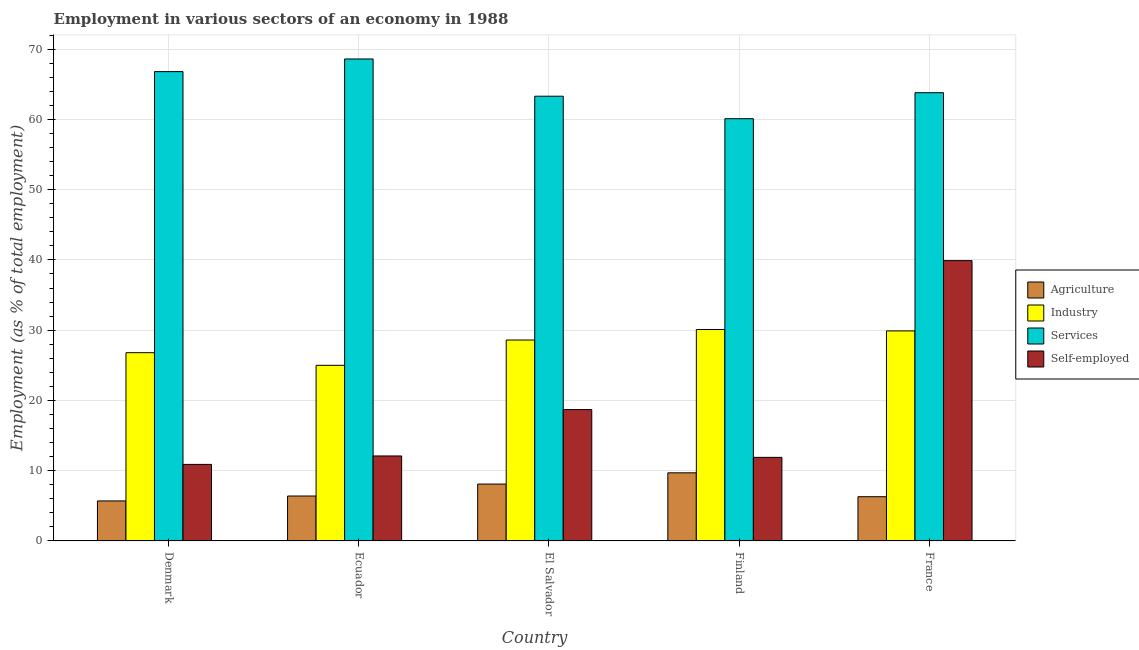How many groups of bars are there?
Provide a short and direct response. 5. Are the number of bars per tick equal to the number of legend labels?
Make the answer very short. Yes. How many bars are there on the 3rd tick from the left?
Offer a terse response. 4. How many bars are there on the 3rd tick from the right?
Make the answer very short. 4. What is the label of the 3rd group of bars from the left?
Provide a short and direct response. El Salvador. What is the percentage of workers in agriculture in France?
Ensure brevity in your answer.  6.3. Across all countries, what is the maximum percentage of workers in agriculture?
Your answer should be compact. 9.7. In which country was the percentage of self employed workers maximum?
Your response must be concise. France. In which country was the percentage of workers in industry minimum?
Your response must be concise. Ecuador. What is the total percentage of workers in services in the graph?
Your answer should be very brief. 322.6. What is the difference between the percentage of workers in industry in Ecuador and that in El Salvador?
Provide a succinct answer. -3.6. What is the difference between the percentage of workers in agriculture in Ecuador and the percentage of self employed workers in El Salvador?
Keep it short and to the point. -12.3. What is the average percentage of workers in industry per country?
Keep it short and to the point. 28.08. What is the difference between the percentage of workers in agriculture and percentage of workers in services in Denmark?
Your answer should be very brief. -61.1. In how many countries, is the percentage of workers in services greater than 10 %?
Offer a terse response. 5. What is the ratio of the percentage of workers in services in Denmark to that in France?
Give a very brief answer. 1.05. Is the percentage of self employed workers in Ecuador less than that in Finland?
Give a very brief answer. No. Is the difference between the percentage of self employed workers in Finland and France greater than the difference between the percentage of workers in services in Finland and France?
Provide a succinct answer. No. What is the difference between the highest and the second highest percentage of workers in agriculture?
Ensure brevity in your answer.  1.6. What is the difference between the highest and the lowest percentage of workers in services?
Keep it short and to the point. 8.5. In how many countries, is the percentage of workers in services greater than the average percentage of workers in services taken over all countries?
Make the answer very short. 2. Is the sum of the percentage of workers in industry in Denmark and Finland greater than the maximum percentage of workers in services across all countries?
Your response must be concise. No. Is it the case that in every country, the sum of the percentage of workers in agriculture and percentage of self employed workers is greater than the sum of percentage of workers in services and percentage of workers in industry?
Your answer should be compact. No. What does the 2nd bar from the left in Denmark represents?
Provide a succinct answer. Industry. What does the 2nd bar from the right in El Salvador represents?
Your answer should be compact. Services. Is it the case that in every country, the sum of the percentage of workers in agriculture and percentage of workers in industry is greater than the percentage of workers in services?
Your response must be concise. No. How many countries are there in the graph?
Your answer should be very brief. 5. Are the values on the major ticks of Y-axis written in scientific E-notation?
Ensure brevity in your answer.  No. Does the graph contain any zero values?
Your answer should be compact. No. How many legend labels are there?
Offer a terse response. 4. How are the legend labels stacked?
Provide a short and direct response. Vertical. What is the title of the graph?
Provide a short and direct response. Employment in various sectors of an economy in 1988. Does "Secondary" appear as one of the legend labels in the graph?
Ensure brevity in your answer.  No. What is the label or title of the Y-axis?
Make the answer very short. Employment (as % of total employment). What is the Employment (as % of total employment) of Agriculture in Denmark?
Ensure brevity in your answer.  5.7. What is the Employment (as % of total employment) in Industry in Denmark?
Your response must be concise. 26.8. What is the Employment (as % of total employment) of Services in Denmark?
Offer a terse response. 66.8. What is the Employment (as % of total employment) of Self-employed in Denmark?
Give a very brief answer. 10.9. What is the Employment (as % of total employment) of Agriculture in Ecuador?
Offer a terse response. 6.4. What is the Employment (as % of total employment) of Services in Ecuador?
Give a very brief answer. 68.6. What is the Employment (as % of total employment) of Self-employed in Ecuador?
Keep it short and to the point. 12.1. What is the Employment (as % of total employment) of Agriculture in El Salvador?
Your answer should be compact. 8.1. What is the Employment (as % of total employment) in Industry in El Salvador?
Your answer should be very brief. 28.6. What is the Employment (as % of total employment) of Services in El Salvador?
Provide a short and direct response. 63.3. What is the Employment (as % of total employment) of Self-employed in El Salvador?
Offer a very short reply. 18.7. What is the Employment (as % of total employment) in Agriculture in Finland?
Offer a terse response. 9.7. What is the Employment (as % of total employment) in Industry in Finland?
Your answer should be very brief. 30.1. What is the Employment (as % of total employment) of Services in Finland?
Make the answer very short. 60.1. What is the Employment (as % of total employment) in Self-employed in Finland?
Provide a short and direct response. 11.9. What is the Employment (as % of total employment) of Agriculture in France?
Your response must be concise. 6.3. What is the Employment (as % of total employment) of Industry in France?
Provide a succinct answer. 29.9. What is the Employment (as % of total employment) of Services in France?
Make the answer very short. 63.8. What is the Employment (as % of total employment) of Self-employed in France?
Offer a terse response. 39.9. Across all countries, what is the maximum Employment (as % of total employment) of Agriculture?
Keep it short and to the point. 9.7. Across all countries, what is the maximum Employment (as % of total employment) of Industry?
Give a very brief answer. 30.1. Across all countries, what is the maximum Employment (as % of total employment) of Services?
Give a very brief answer. 68.6. Across all countries, what is the maximum Employment (as % of total employment) of Self-employed?
Ensure brevity in your answer.  39.9. Across all countries, what is the minimum Employment (as % of total employment) in Agriculture?
Your answer should be compact. 5.7. Across all countries, what is the minimum Employment (as % of total employment) of Services?
Give a very brief answer. 60.1. Across all countries, what is the minimum Employment (as % of total employment) in Self-employed?
Give a very brief answer. 10.9. What is the total Employment (as % of total employment) of Agriculture in the graph?
Make the answer very short. 36.2. What is the total Employment (as % of total employment) of Industry in the graph?
Provide a succinct answer. 140.4. What is the total Employment (as % of total employment) of Services in the graph?
Your answer should be compact. 322.6. What is the total Employment (as % of total employment) of Self-employed in the graph?
Ensure brevity in your answer.  93.5. What is the difference between the Employment (as % of total employment) of Agriculture in Denmark and that in Ecuador?
Offer a terse response. -0.7. What is the difference between the Employment (as % of total employment) of Industry in Denmark and that in Ecuador?
Offer a very short reply. 1.8. What is the difference between the Employment (as % of total employment) in Self-employed in Denmark and that in Ecuador?
Ensure brevity in your answer.  -1.2. What is the difference between the Employment (as % of total employment) in Agriculture in Denmark and that in El Salvador?
Keep it short and to the point. -2.4. What is the difference between the Employment (as % of total employment) of Services in Denmark and that in El Salvador?
Ensure brevity in your answer.  3.5. What is the difference between the Employment (as % of total employment) of Self-employed in Denmark and that in El Salvador?
Your response must be concise. -7.8. What is the difference between the Employment (as % of total employment) of Services in Denmark and that in Finland?
Make the answer very short. 6.7. What is the difference between the Employment (as % of total employment) of Self-employed in Denmark and that in Finland?
Your response must be concise. -1. What is the difference between the Employment (as % of total employment) in Agriculture in Denmark and that in France?
Offer a very short reply. -0.6. What is the difference between the Employment (as % of total employment) in Services in Denmark and that in France?
Offer a terse response. 3. What is the difference between the Employment (as % of total employment) in Self-employed in Denmark and that in France?
Make the answer very short. -29. What is the difference between the Employment (as % of total employment) of Industry in Ecuador and that in El Salvador?
Give a very brief answer. -3.6. What is the difference between the Employment (as % of total employment) of Industry in Ecuador and that in Finland?
Offer a very short reply. -5.1. What is the difference between the Employment (as % of total employment) in Self-employed in Ecuador and that in Finland?
Provide a succinct answer. 0.2. What is the difference between the Employment (as % of total employment) of Self-employed in Ecuador and that in France?
Offer a terse response. -27.8. What is the difference between the Employment (as % of total employment) of Agriculture in El Salvador and that in Finland?
Offer a terse response. -1.6. What is the difference between the Employment (as % of total employment) in Industry in El Salvador and that in Finland?
Your answer should be compact. -1.5. What is the difference between the Employment (as % of total employment) in Agriculture in El Salvador and that in France?
Give a very brief answer. 1.8. What is the difference between the Employment (as % of total employment) of Industry in El Salvador and that in France?
Your answer should be compact. -1.3. What is the difference between the Employment (as % of total employment) in Services in El Salvador and that in France?
Your answer should be very brief. -0.5. What is the difference between the Employment (as % of total employment) of Self-employed in El Salvador and that in France?
Make the answer very short. -21.2. What is the difference between the Employment (as % of total employment) in Agriculture in Finland and that in France?
Ensure brevity in your answer.  3.4. What is the difference between the Employment (as % of total employment) in Industry in Finland and that in France?
Your answer should be very brief. 0.2. What is the difference between the Employment (as % of total employment) in Services in Finland and that in France?
Offer a terse response. -3.7. What is the difference between the Employment (as % of total employment) in Self-employed in Finland and that in France?
Ensure brevity in your answer.  -28. What is the difference between the Employment (as % of total employment) of Agriculture in Denmark and the Employment (as % of total employment) of Industry in Ecuador?
Give a very brief answer. -19.3. What is the difference between the Employment (as % of total employment) in Agriculture in Denmark and the Employment (as % of total employment) in Services in Ecuador?
Keep it short and to the point. -62.9. What is the difference between the Employment (as % of total employment) of Industry in Denmark and the Employment (as % of total employment) of Services in Ecuador?
Provide a succinct answer. -41.8. What is the difference between the Employment (as % of total employment) of Services in Denmark and the Employment (as % of total employment) of Self-employed in Ecuador?
Your response must be concise. 54.7. What is the difference between the Employment (as % of total employment) of Agriculture in Denmark and the Employment (as % of total employment) of Industry in El Salvador?
Your answer should be very brief. -22.9. What is the difference between the Employment (as % of total employment) of Agriculture in Denmark and the Employment (as % of total employment) of Services in El Salvador?
Keep it short and to the point. -57.6. What is the difference between the Employment (as % of total employment) of Agriculture in Denmark and the Employment (as % of total employment) of Self-employed in El Salvador?
Your answer should be very brief. -13. What is the difference between the Employment (as % of total employment) in Industry in Denmark and the Employment (as % of total employment) in Services in El Salvador?
Provide a succinct answer. -36.5. What is the difference between the Employment (as % of total employment) in Services in Denmark and the Employment (as % of total employment) in Self-employed in El Salvador?
Offer a very short reply. 48.1. What is the difference between the Employment (as % of total employment) of Agriculture in Denmark and the Employment (as % of total employment) of Industry in Finland?
Offer a very short reply. -24.4. What is the difference between the Employment (as % of total employment) in Agriculture in Denmark and the Employment (as % of total employment) in Services in Finland?
Your answer should be compact. -54.4. What is the difference between the Employment (as % of total employment) of Industry in Denmark and the Employment (as % of total employment) of Services in Finland?
Ensure brevity in your answer.  -33.3. What is the difference between the Employment (as % of total employment) of Industry in Denmark and the Employment (as % of total employment) of Self-employed in Finland?
Offer a very short reply. 14.9. What is the difference between the Employment (as % of total employment) in Services in Denmark and the Employment (as % of total employment) in Self-employed in Finland?
Offer a terse response. 54.9. What is the difference between the Employment (as % of total employment) of Agriculture in Denmark and the Employment (as % of total employment) of Industry in France?
Your response must be concise. -24.2. What is the difference between the Employment (as % of total employment) of Agriculture in Denmark and the Employment (as % of total employment) of Services in France?
Provide a succinct answer. -58.1. What is the difference between the Employment (as % of total employment) of Agriculture in Denmark and the Employment (as % of total employment) of Self-employed in France?
Provide a short and direct response. -34.2. What is the difference between the Employment (as % of total employment) in Industry in Denmark and the Employment (as % of total employment) in Services in France?
Your answer should be compact. -37. What is the difference between the Employment (as % of total employment) in Industry in Denmark and the Employment (as % of total employment) in Self-employed in France?
Provide a short and direct response. -13.1. What is the difference between the Employment (as % of total employment) in Services in Denmark and the Employment (as % of total employment) in Self-employed in France?
Offer a very short reply. 26.9. What is the difference between the Employment (as % of total employment) in Agriculture in Ecuador and the Employment (as % of total employment) in Industry in El Salvador?
Make the answer very short. -22.2. What is the difference between the Employment (as % of total employment) in Agriculture in Ecuador and the Employment (as % of total employment) in Services in El Salvador?
Ensure brevity in your answer.  -56.9. What is the difference between the Employment (as % of total employment) of Industry in Ecuador and the Employment (as % of total employment) of Services in El Salvador?
Make the answer very short. -38.3. What is the difference between the Employment (as % of total employment) in Industry in Ecuador and the Employment (as % of total employment) in Self-employed in El Salvador?
Your response must be concise. 6.3. What is the difference between the Employment (as % of total employment) of Services in Ecuador and the Employment (as % of total employment) of Self-employed in El Salvador?
Give a very brief answer. 49.9. What is the difference between the Employment (as % of total employment) of Agriculture in Ecuador and the Employment (as % of total employment) of Industry in Finland?
Ensure brevity in your answer.  -23.7. What is the difference between the Employment (as % of total employment) of Agriculture in Ecuador and the Employment (as % of total employment) of Services in Finland?
Ensure brevity in your answer.  -53.7. What is the difference between the Employment (as % of total employment) in Industry in Ecuador and the Employment (as % of total employment) in Services in Finland?
Make the answer very short. -35.1. What is the difference between the Employment (as % of total employment) of Industry in Ecuador and the Employment (as % of total employment) of Self-employed in Finland?
Provide a short and direct response. 13.1. What is the difference between the Employment (as % of total employment) in Services in Ecuador and the Employment (as % of total employment) in Self-employed in Finland?
Give a very brief answer. 56.7. What is the difference between the Employment (as % of total employment) of Agriculture in Ecuador and the Employment (as % of total employment) of Industry in France?
Give a very brief answer. -23.5. What is the difference between the Employment (as % of total employment) in Agriculture in Ecuador and the Employment (as % of total employment) in Services in France?
Provide a short and direct response. -57.4. What is the difference between the Employment (as % of total employment) of Agriculture in Ecuador and the Employment (as % of total employment) of Self-employed in France?
Keep it short and to the point. -33.5. What is the difference between the Employment (as % of total employment) of Industry in Ecuador and the Employment (as % of total employment) of Services in France?
Give a very brief answer. -38.8. What is the difference between the Employment (as % of total employment) in Industry in Ecuador and the Employment (as % of total employment) in Self-employed in France?
Give a very brief answer. -14.9. What is the difference between the Employment (as % of total employment) in Services in Ecuador and the Employment (as % of total employment) in Self-employed in France?
Your answer should be very brief. 28.7. What is the difference between the Employment (as % of total employment) of Agriculture in El Salvador and the Employment (as % of total employment) of Services in Finland?
Give a very brief answer. -52. What is the difference between the Employment (as % of total employment) of Agriculture in El Salvador and the Employment (as % of total employment) of Self-employed in Finland?
Ensure brevity in your answer.  -3.8. What is the difference between the Employment (as % of total employment) of Industry in El Salvador and the Employment (as % of total employment) of Services in Finland?
Make the answer very short. -31.5. What is the difference between the Employment (as % of total employment) in Industry in El Salvador and the Employment (as % of total employment) in Self-employed in Finland?
Make the answer very short. 16.7. What is the difference between the Employment (as % of total employment) of Services in El Salvador and the Employment (as % of total employment) of Self-employed in Finland?
Keep it short and to the point. 51.4. What is the difference between the Employment (as % of total employment) in Agriculture in El Salvador and the Employment (as % of total employment) in Industry in France?
Your answer should be compact. -21.8. What is the difference between the Employment (as % of total employment) in Agriculture in El Salvador and the Employment (as % of total employment) in Services in France?
Provide a succinct answer. -55.7. What is the difference between the Employment (as % of total employment) of Agriculture in El Salvador and the Employment (as % of total employment) of Self-employed in France?
Offer a very short reply. -31.8. What is the difference between the Employment (as % of total employment) of Industry in El Salvador and the Employment (as % of total employment) of Services in France?
Your answer should be compact. -35.2. What is the difference between the Employment (as % of total employment) in Services in El Salvador and the Employment (as % of total employment) in Self-employed in France?
Your answer should be compact. 23.4. What is the difference between the Employment (as % of total employment) in Agriculture in Finland and the Employment (as % of total employment) in Industry in France?
Give a very brief answer. -20.2. What is the difference between the Employment (as % of total employment) of Agriculture in Finland and the Employment (as % of total employment) of Services in France?
Your response must be concise. -54.1. What is the difference between the Employment (as % of total employment) of Agriculture in Finland and the Employment (as % of total employment) of Self-employed in France?
Provide a succinct answer. -30.2. What is the difference between the Employment (as % of total employment) in Industry in Finland and the Employment (as % of total employment) in Services in France?
Your answer should be compact. -33.7. What is the difference between the Employment (as % of total employment) in Industry in Finland and the Employment (as % of total employment) in Self-employed in France?
Your response must be concise. -9.8. What is the difference between the Employment (as % of total employment) in Services in Finland and the Employment (as % of total employment) in Self-employed in France?
Keep it short and to the point. 20.2. What is the average Employment (as % of total employment) in Agriculture per country?
Offer a terse response. 7.24. What is the average Employment (as % of total employment) of Industry per country?
Provide a succinct answer. 28.08. What is the average Employment (as % of total employment) in Services per country?
Make the answer very short. 64.52. What is the average Employment (as % of total employment) of Self-employed per country?
Give a very brief answer. 18.7. What is the difference between the Employment (as % of total employment) of Agriculture and Employment (as % of total employment) of Industry in Denmark?
Your response must be concise. -21.1. What is the difference between the Employment (as % of total employment) in Agriculture and Employment (as % of total employment) in Services in Denmark?
Make the answer very short. -61.1. What is the difference between the Employment (as % of total employment) in Industry and Employment (as % of total employment) in Services in Denmark?
Offer a terse response. -40. What is the difference between the Employment (as % of total employment) in Industry and Employment (as % of total employment) in Self-employed in Denmark?
Make the answer very short. 15.9. What is the difference between the Employment (as % of total employment) in Services and Employment (as % of total employment) in Self-employed in Denmark?
Provide a succinct answer. 55.9. What is the difference between the Employment (as % of total employment) of Agriculture and Employment (as % of total employment) of Industry in Ecuador?
Ensure brevity in your answer.  -18.6. What is the difference between the Employment (as % of total employment) in Agriculture and Employment (as % of total employment) in Services in Ecuador?
Provide a short and direct response. -62.2. What is the difference between the Employment (as % of total employment) of Agriculture and Employment (as % of total employment) of Self-employed in Ecuador?
Your response must be concise. -5.7. What is the difference between the Employment (as % of total employment) in Industry and Employment (as % of total employment) in Services in Ecuador?
Give a very brief answer. -43.6. What is the difference between the Employment (as % of total employment) of Services and Employment (as % of total employment) of Self-employed in Ecuador?
Offer a very short reply. 56.5. What is the difference between the Employment (as % of total employment) in Agriculture and Employment (as % of total employment) in Industry in El Salvador?
Give a very brief answer. -20.5. What is the difference between the Employment (as % of total employment) in Agriculture and Employment (as % of total employment) in Services in El Salvador?
Offer a very short reply. -55.2. What is the difference between the Employment (as % of total employment) in Industry and Employment (as % of total employment) in Services in El Salvador?
Your response must be concise. -34.7. What is the difference between the Employment (as % of total employment) of Industry and Employment (as % of total employment) of Self-employed in El Salvador?
Provide a succinct answer. 9.9. What is the difference between the Employment (as % of total employment) of Services and Employment (as % of total employment) of Self-employed in El Salvador?
Give a very brief answer. 44.6. What is the difference between the Employment (as % of total employment) of Agriculture and Employment (as % of total employment) of Industry in Finland?
Provide a short and direct response. -20.4. What is the difference between the Employment (as % of total employment) of Agriculture and Employment (as % of total employment) of Services in Finland?
Ensure brevity in your answer.  -50.4. What is the difference between the Employment (as % of total employment) of Agriculture and Employment (as % of total employment) of Self-employed in Finland?
Ensure brevity in your answer.  -2.2. What is the difference between the Employment (as % of total employment) in Industry and Employment (as % of total employment) in Services in Finland?
Give a very brief answer. -30. What is the difference between the Employment (as % of total employment) of Industry and Employment (as % of total employment) of Self-employed in Finland?
Your response must be concise. 18.2. What is the difference between the Employment (as % of total employment) in Services and Employment (as % of total employment) in Self-employed in Finland?
Offer a very short reply. 48.2. What is the difference between the Employment (as % of total employment) of Agriculture and Employment (as % of total employment) of Industry in France?
Offer a very short reply. -23.6. What is the difference between the Employment (as % of total employment) in Agriculture and Employment (as % of total employment) in Services in France?
Keep it short and to the point. -57.5. What is the difference between the Employment (as % of total employment) of Agriculture and Employment (as % of total employment) of Self-employed in France?
Give a very brief answer. -33.6. What is the difference between the Employment (as % of total employment) of Industry and Employment (as % of total employment) of Services in France?
Provide a short and direct response. -33.9. What is the difference between the Employment (as % of total employment) in Services and Employment (as % of total employment) in Self-employed in France?
Make the answer very short. 23.9. What is the ratio of the Employment (as % of total employment) of Agriculture in Denmark to that in Ecuador?
Your response must be concise. 0.89. What is the ratio of the Employment (as % of total employment) in Industry in Denmark to that in Ecuador?
Provide a short and direct response. 1.07. What is the ratio of the Employment (as % of total employment) in Services in Denmark to that in Ecuador?
Provide a short and direct response. 0.97. What is the ratio of the Employment (as % of total employment) in Self-employed in Denmark to that in Ecuador?
Provide a succinct answer. 0.9. What is the ratio of the Employment (as % of total employment) in Agriculture in Denmark to that in El Salvador?
Ensure brevity in your answer.  0.7. What is the ratio of the Employment (as % of total employment) of Industry in Denmark to that in El Salvador?
Keep it short and to the point. 0.94. What is the ratio of the Employment (as % of total employment) of Services in Denmark to that in El Salvador?
Offer a very short reply. 1.06. What is the ratio of the Employment (as % of total employment) of Self-employed in Denmark to that in El Salvador?
Your answer should be compact. 0.58. What is the ratio of the Employment (as % of total employment) in Agriculture in Denmark to that in Finland?
Make the answer very short. 0.59. What is the ratio of the Employment (as % of total employment) in Industry in Denmark to that in Finland?
Your response must be concise. 0.89. What is the ratio of the Employment (as % of total employment) of Services in Denmark to that in Finland?
Your answer should be compact. 1.11. What is the ratio of the Employment (as % of total employment) of Self-employed in Denmark to that in Finland?
Your response must be concise. 0.92. What is the ratio of the Employment (as % of total employment) of Agriculture in Denmark to that in France?
Give a very brief answer. 0.9. What is the ratio of the Employment (as % of total employment) in Industry in Denmark to that in France?
Your answer should be compact. 0.9. What is the ratio of the Employment (as % of total employment) of Services in Denmark to that in France?
Provide a short and direct response. 1.05. What is the ratio of the Employment (as % of total employment) in Self-employed in Denmark to that in France?
Make the answer very short. 0.27. What is the ratio of the Employment (as % of total employment) in Agriculture in Ecuador to that in El Salvador?
Make the answer very short. 0.79. What is the ratio of the Employment (as % of total employment) in Industry in Ecuador to that in El Salvador?
Keep it short and to the point. 0.87. What is the ratio of the Employment (as % of total employment) of Services in Ecuador to that in El Salvador?
Offer a terse response. 1.08. What is the ratio of the Employment (as % of total employment) of Self-employed in Ecuador to that in El Salvador?
Your answer should be very brief. 0.65. What is the ratio of the Employment (as % of total employment) of Agriculture in Ecuador to that in Finland?
Provide a succinct answer. 0.66. What is the ratio of the Employment (as % of total employment) in Industry in Ecuador to that in Finland?
Offer a terse response. 0.83. What is the ratio of the Employment (as % of total employment) in Services in Ecuador to that in Finland?
Your answer should be very brief. 1.14. What is the ratio of the Employment (as % of total employment) in Self-employed in Ecuador to that in Finland?
Offer a terse response. 1.02. What is the ratio of the Employment (as % of total employment) of Agriculture in Ecuador to that in France?
Keep it short and to the point. 1.02. What is the ratio of the Employment (as % of total employment) of Industry in Ecuador to that in France?
Offer a very short reply. 0.84. What is the ratio of the Employment (as % of total employment) of Services in Ecuador to that in France?
Keep it short and to the point. 1.08. What is the ratio of the Employment (as % of total employment) of Self-employed in Ecuador to that in France?
Your answer should be compact. 0.3. What is the ratio of the Employment (as % of total employment) in Agriculture in El Salvador to that in Finland?
Ensure brevity in your answer.  0.84. What is the ratio of the Employment (as % of total employment) of Industry in El Salvador to that in Finland?
Give a very brief answer. 0.95. What is the ratio of the Employment (as % of total employment) in Services in El Salvador to that in Finland?
Provide a short and direct response. 1.05. What is the ratio of the Employment (as % of total employment) in Self-employed in El Salvador to that in Finland?
Your response must be concise. 1.57. What is the ratio of the Employment (as % of total employment) in Industry in El Salvador to that in France?
Your answer should be compact. 0.96. What is the ratio of the Employment (as % of total employment) in Services in El Salvador to that in France?
Make the answer very short. 0.99. What is the ratio of the Employment (as % of total employment) of Self-employed in El Salvador to that in France?
Offer a terse response. 0.47. What is the ratio of the Employment (as % of total employment) of Agriculture in Finland to that in France?
Provide a short and direct response. 1.54. What is the ratio of the Employment (as % of total employment) in Services in Finland to that in France?
Your answer should be very brief. 0.94. What is the ratio of the Employment (as % of total employment) in Self-employed in Finland to that in France?
Your answer should be compact. 0.3. What is the difference between the highest and the second highest Employment (as % of total employment) in Agriculture?
Provide a short and direct response. 1.6. What is the difference between the highest and the second highest Employment (as % of total employment) of Services?
Offer a very short reply. 1.8. What is the difference between the highest and the second highest Employment (as % of total employment) in Self-employed?
Ensure brevity in your answer.  21.2. 